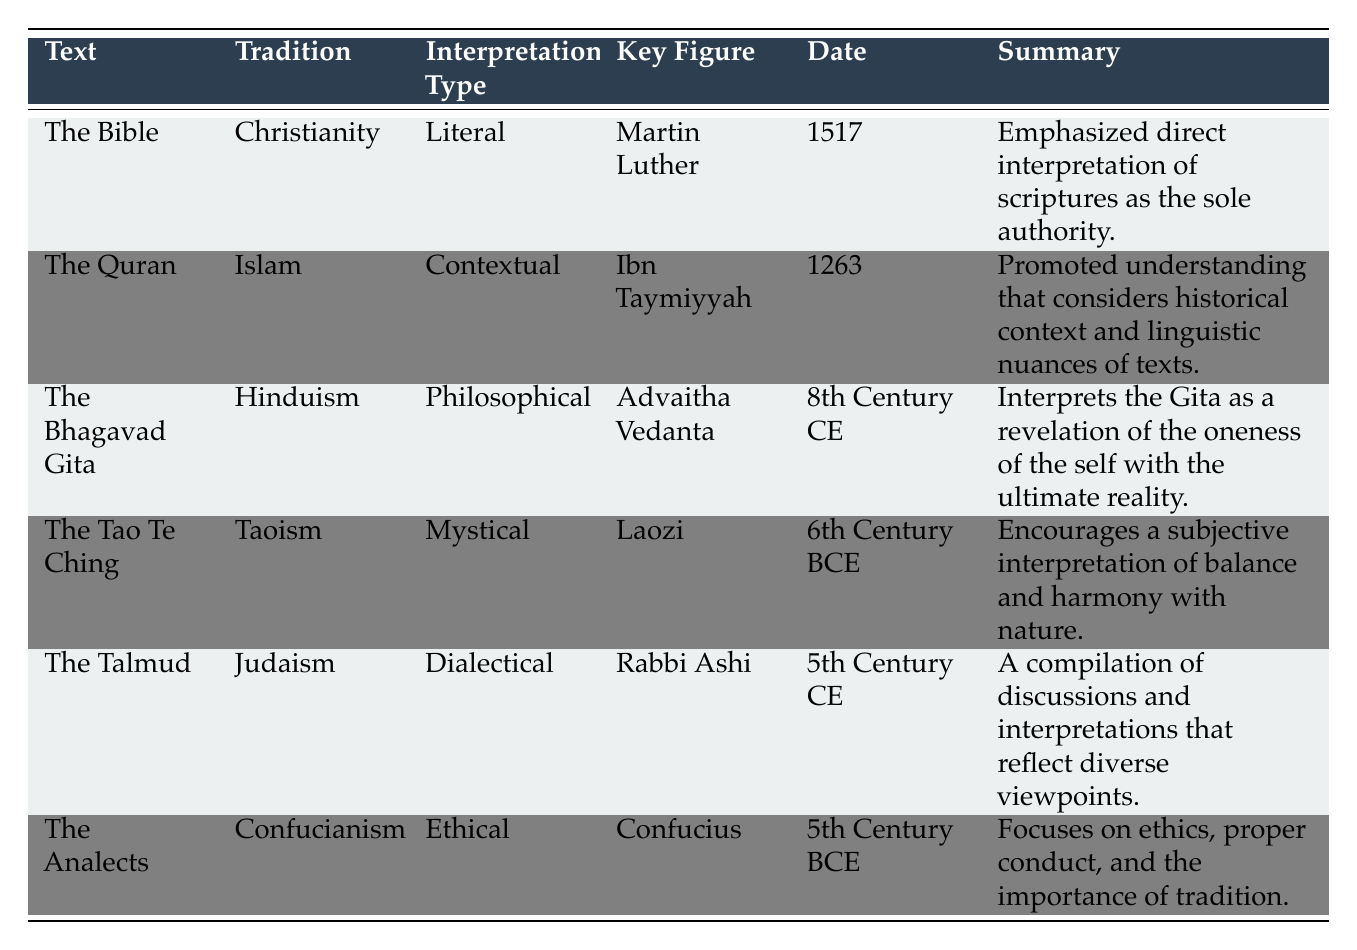What is the interpretation type associated with The Bible? The table indicates that the interpretation type associated with The Bible is "Literal."
Answer: Literal Who is the key figure associated with the interpretation of The Quran? According to the table, the key figure associated with the interpretation of The Quran is "Ibn Taymiyyah."
Answer: Ibn Taymiyyah Is the date of the interpretation of The Analects earlier than that of The Talmud? The date for The Analects is the 5th Century BCE, and for The Talmud, it is the 5th Century CE. Since BCE is earlier than CE, the statement is true.
Answer: Yes Which text is interpreted philosophically by Advaitha Vedanta? The table states that The Bhagavad Gita is the text interpreted philosophically by Advaitha Vedanta.
Answer: The Bhagavad Gita How many different interpretation types are represented in the table? The interpretation types listed are Literal, Contextual, Philosophical, Mystical, Dialectical, and Ethical, totaling six distinct types.
Answer: 6 What is the common context shared between The Talmud and The Bible? Both The Talmud and The Bible are related to religious traditions. However, the specific context is distinct; The Talmud focuses on Jewish law and ethics, while The Bible emphasizes the Reformation context. Therefore, the commonality may be seen as both being foundational texts in their respective religious traditions.
Answer: No common specific context Which text has an interpretation type that promotes a subjective understanding? The Tao Te Ching is identified as having an interpretation type that encourages a subjective interpretation of balance and harmony with nature.
Answer: The Tao Te Ching Identify the earliest key figure mentioned in the table. The earliest key figure mentioned is "Laozi," associated with The Tao Te Ching from the 6th Century BCE, which is earlier than all other figures listed.
Answer: Laozi Based on the summary, what does Rabbi Ashi's interpretation encompass? Rabbi Ashi's interpretation encompasses a dialectical approach that compiles discussions and diverse viewpoints on Jewish law and ethics.
Answer: Dialectical approach on Jewish law and ethics 